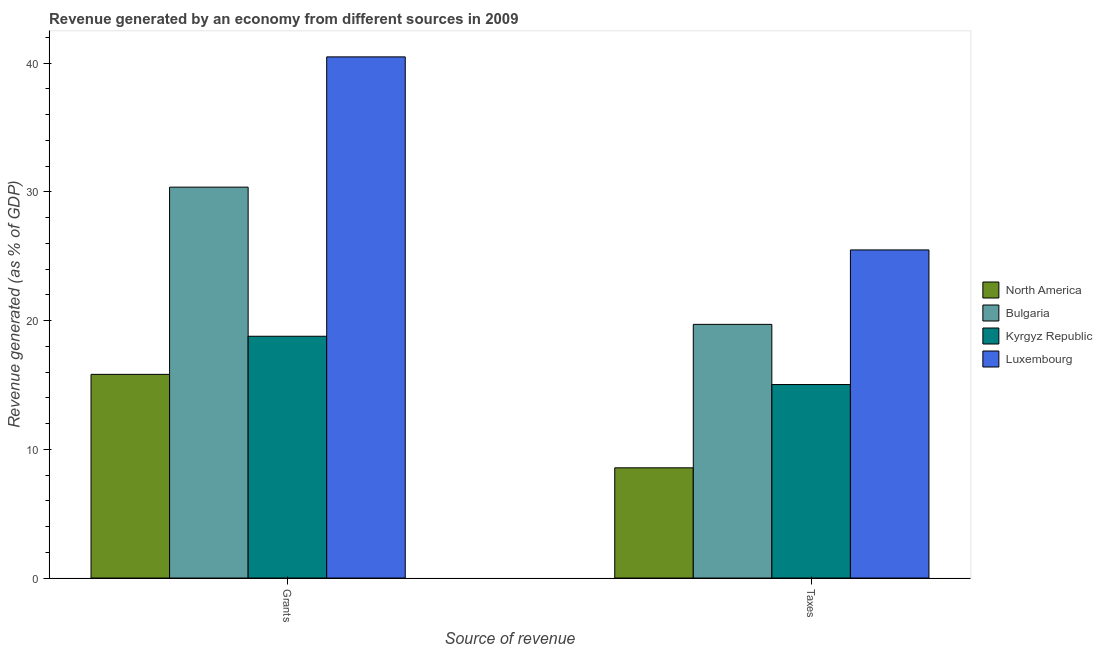How many groups of bars are there?
Offer a terse response. 2. Are the number of bars per tick equal to the number of legend labels?
Give a very brief answer. Yes. Are the number of bars on each tick of the X-axis equal?
Your answer should be very brief. Yes. What is the label of the 1st group of bars from the left?
Keep it short and to the point. Grants. What is the revenue generated by taxes in Luxembourg?
Your answer should be very brief. 25.5. Across all countries, what is the maximum revenue generated by taxes?
Offer a very short reply. 25.5. Across all countries, what is the minimum revenue generated by taxes?
Keep it short and to the point. 8.56. In which country was the revenue generated by grants maximum?
Offer a terse response. Luxembourg. In which country was the revenue generated by taxes minimum?
Make the answer very short. North America. What is the total revenue generated by taxes in the graph?
Keep it short and to the point. 68.81. What is the difference between the revenue generated by grants in Kyrgyz Republic and that in Luxembourg?
Ensure brevity in your answer.  -21.71. What is the difference between the revenue generated by taxes in North America and the revenue generated by grants in Kyrgyz Republic?
Provide a succinct answer. -10.22. What is the average revenue generated by grants per country?
Keep it short and to the point. 26.37. What is the difference between the revenue generated by taxes and revenue generated by grants in North America?
Your answer should be compact. -7.26. In how many countries, is the revenue generated by grants greater than 2 %?
Your answer should be very brief. 4. What is the ratio of the revenue generated by taxes in Luxembourg to that in Bulgaria?
Make the answer very short. 1.29. What does the 3rd bar from the left in Grants represents?
Give a very brief answer. Kyrgyz Republic. How many bars are there?
Offer a very short reply. 8. What is the difference between two consecutive major ticks on the Y-axis?
Offer a terse response. 10. Are the values on the major ticks of Y-axis written in scientific E-notation?
Keep it short and to the point. No. Does the graph contain any zero values?
Your answer should be compact. No. Does the graph contain grids?
Provide a succinct answer. No. Where does the legend appear in the graph?
Offer a terse response. Center right. How many legend labels are there?
Ensure brevity in your answer.  4. What is the title of the graph?
Your answer should be very brief. Revenue generated by an economy from different sources in 2009. What is the label or title of the X-axis?
Keep it short and to the point. Source of revenue. What is the label or title of the Y-axis?
Make the answer very short. Revenue generated (as % of GDP). What is the Revenue generated (as % of GDP) in North America in Grants?
Give a very brief answer. 15.83. What is the Revenue generated (as % of GDP) of Bulgaria in Grants?
Give a very brief answer. 30.37. What is the Revenue generated (as % of GDP) of Kyrgyz Republic in Grants?
Offer a very short reply. 18.79. What is the Revenue generated (as % of GDP) of Luxembourg in Grants?
Offer a very short reply. 40.5. What is the Revenue generated (as % of GDP) in North America in Taxes?
Give a very brief answer. 8.56. What is the Revenue generated (as % of GDP) of Bulgaria in Taxes?
Provide a succinct answer. 19.71. What is the Revenue generated (as % of GDP) in Kyrgyz Republic in Taxes?
Your answer should be compact. 15.04. What is the Revenue generated (as % of GDP) of Luxembourg in Taxes?
Offer a very short reply. 25.5. Across all Source of revenue, what is the maximum Revenue generated (as % of GDP) of North America?
Keep it short and to the point. 15.83. Across all Source of revenue, what is the maximum Revenue generated (as % of GDP) in Bulgaria?
Give a very brief answer. 30.37. Across all Source of revenue, what is the maximum Revenue generated (as % of GDP) of Kyrgyz Republic?
Your response must be concise. 18.79. Across all Source of revenue, what is the maximum Revenue generated (as % of GDP) of Luxembourg?
Offer a very short reply. 40.5. Across all Source of revenue, what is the minimum Revenue generated (as % of GDP) in North America?
Your answer should be compact. 8.56. Across all Source of revenue, what is the minimum Revenue generated (as % of GDP) of Bulgaria?
Give a very brief answer. 19.71. Across all Source of revenue, what is the minimum Revenue generated (as % of GDP) in Kyrgyz Republic?
Make the answer very short. 15.04. Across all Source of revenue, what is the minimum Revenue generated (as % of GDP) in Luxembourg?
Your response must be concise. 25.5. What is the total Revenue generated (as % of GDP) of North America in the graph?
Offer a very short reply. 24.39. What is the total Revenue generated (as % of GDP) in Bulgaria in the graph?
Give a very brief answer. 50.08. What is the total Revenue generated (as % of GDP) in Kyrgyz Republic in the graph?
Keep it short and to the point. 33.82. What is the total Revenue generated (as % of GDP) of Luxembourg in the graph?
Give a very brief answer. 65.99. What is the difference between the Revenue generated (as % of GDP) of North America in Grants and that in Taxes?
Provide a succinct answer. 7.26. What is the difference between the Revenue generated (as % of GDP) of Bulgaria in Grants and that in Taxes?
Make the answer very short. 10.66. What is the difference between the Revenue generated (as % of GDP) of Kyrgyz Republic in Grants and that in Taxes?
Offer a terse response. 3.75. What is the difference between the Revenue generated (as % of GDP) in Luxembourg in Grants and that in Taxes?
Provide a short and direct response. 15. What is the difference between the Revenue generated (as % of GDP) in North America in Grants and the Revenue generated (as % of GDP) in Bulgaria in Taxes?
Keep it short and to the point. -3.88. What is the difference between the Revenue generated (as % of GDP) of North America in Grants and the Revenue generated (as % of GDP) of Kyrgyz Republic in Taxes?
Your answer should be very brief. 0.79. What is the difference between the Revenue generated (as % of GDP) of North America in Grants and the Revenue generated (as % of GDP) of Luxembourg in Taxes?
Offer a very short reply. -9.67. What is the difference between the Revenue generated (as % of GDP) of Bulgaria in Grants and the Revenue generated (as % of GDP) of Kyrgyz Republic in Taxes?
Offer a terse response. 15.34. What is the difference between the Revenue generated (as % of GDP) of Bulgaria in Grants and the Revenue generated (as % of GDP) of Luxembourg in Taxes?
Provide a short and direct response. 4.88. What is the difference between the Revenue generated (as % of GDP) of Kyrgyz Republic in Grants and the Revenue generated (as % of GDP) of Luxembourg in Taxes?
Offer a very short reply. -6.71. What is the average Revenue generated (as % of GDP) of North America per Source of revenue?
Provide a short and direct response. 12.2. What is the average Revenue generated (as % of GDP) in Bulgaria per Source of revenue?
Your answer should be compact. 25.04. What is the average Revenue generated (as % of GDP) in Kyrgyz Republic per Source of revenue?
Give a very brief answer. 16.91. What is the average Revenue generated (as % of GDP) in Luxembourg per Source of revenue?
Your answer should be very brief. 33. What is the difference between the Revenue generated (as % of GDP) in North America and Revenue generated (as % of GDP) in Bulgaria in Grants?
Your response must be concise. -14.55. What is the difference between the Revenue generated (as % of GDP) of North America and Revenue generated (as % of GDP) of Kyrgyz Republic in Grants?
Your answer should be compact. -2.96. What is the difference between the Revenue generated (as % of GDP) of North America and Revenue generated (as % of GDP) of Luxembourg in Grants?
Offer a very short reply. -24.67. What is the difference between the Revenue generated (as % of GDP) in Bulgaria and Revenue generated (as % of GDP) in Kyrgyz Republic in Grants?
Provide a succinct answer. 11.59. What is the difference between the Revenue generated (as % of GDP) of Bulgaria and Revenue generated (as % of GDP) of Luxembourg in Grants?
Ensure brevity in your answer.  -10.12. What is the difference between the Revenue generated (as % of GDP) of Kyrgyz Republic and Revenue generated (as % of GDP) of Luxembourg in Grants?
Your answer should be compact. -21.71. What is the difference between the Revenue generated (as % of GDP) in North America and Revenue generated (as % of GDP) in Bulgaria in Taxes?
Your response must be concise. -11.15. What is the difference between the Revenue generated (as % of GDP) of North America and Revenue generated (as % of GDP) of Kyrgyz Republic in Taxes?
Ensure brevity in your answer.  -6.47. What is the difference between the Revenue generated (as % of GDP) in North America and Revenue generated (as % of GDP) in Luxembourg in Taxes?
Offer a very short reply. -16.93. What is the difference between the Revenue generated (as % of GDP) in Bulgaria and Revenue generated (as % of GDP) in Kyrgyz Republic in Taxes?
Provide a succinct answer. 4.67. What is the difference between the Revenue generated (as % of GDP) of Bulgaria and Revenue generated (as % of GDP) of Luxembourg in Taxes?
Give a very brief answer. -5.78. What is the difference between the Revenue generated (as % of GDP) in Kyrgyz Republic and Revenue generated (as % of GDP) in Luxembourg in Taxes?
Give a very brief answer. -10.46. What is the ratio of the Revenue generated (as % of GDP) of North America in Grants to that in Taxes?
Offer a terse response. 1.85. What is the ratio of the Revenue generated (as % of GDP) of Bulgaria in Grants to that in Taxes?
Make the answer very short. 1.54. What is the ratio of the Revenue generated (as % of GDP) in Kyrgyz Republic in Grants to that in Taxes?
Make the answer very short. 1.25. What is the ratio of the Revenue generated (as % of GDP) of Luxembourg in Grants to that in Taxes?
Offer a terse response. 1.59. What is the difference between the highest and the second highest Revenue generated (as % of GDP) of North America?
Provide a succinct answer. 7.26. What is the difference between the highest and the second highest Revenue generated (as % of GDP) of Bulgaria?
Your answer should be compact. 10.66. What is the difference between the highest and the second highest Revenue generated (as % of GDP) in Kyrgyz Republic?
Keep it short and to the point. 3.75. What is the difference between the highest and the second highest Revenue generated (as % of GDP) of Luxembourg?
Give a very brief answer. 15. What is the difference between the highest and the lowest Revenue generated (as % of GDP) of North America?
Your answer should be very brief. 7.26. What is the difference between the highest and the lowest Revenue generated (as % of GDP) of Bulgaria?
Provide a short and direct response. 10.66. What is the difference between the highest and the lowest Revenue generated (as % of GDP) in Kyrgyz Republic?
Offer a terse response. 3.75. What is the difference between the highest and the lowest Revenue generated (as % of GDP) in Luxembourg?
Give a very brief answer. 15. 